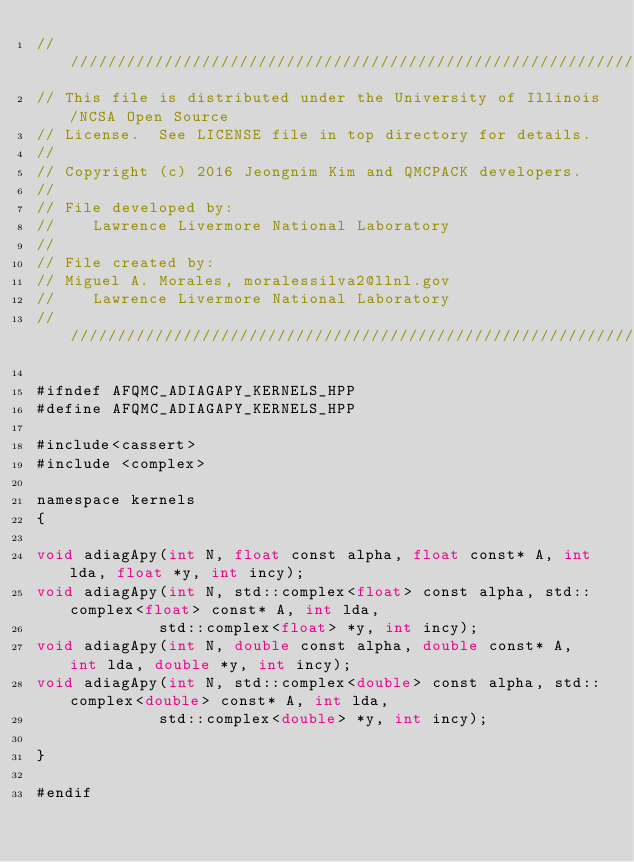<code> <loc_0><loc_0><loc_500><loc_500><_Cuda_>//////////////////////////////////////////////////////////////////////
// This file is distributed under the University of Illinois/NCSA Open Source
// License.  See LICENSE file in top directory for details.
//
// Copyright (c) 2016 Jeongnim Kim and QMCPACK developers.
//
// File developed by:
//    Lawrence Livermore National Laboratory
//
// File created by:
// Miguel A. Morales, moralessilva2@llnl.gov
//    Lawrence Livermore National Laboratory
////////////////////////////////////////////////////////////////////////////////

#ifndef AFQMC_ADIAGAPY_KERNELS_HPP
#define AFQMC_ADIAGAPY_KERNELS_HPP

#include<cassert>
#include <complex>

namespace kernels
{

void adiagApy(int N, float const alpha, float const* A, int lda, float *y, int incy); 
void adiagApy(int N, std::complex<float> const alpha, std::complex<float> const* A, int lda, 
             std::complex<float> *y, int incy); 
void adiagApy(int N, double const alpha, double const* A, int lda, double *y, int incy); 
void adiagApy(int N, std::complex<double> const alpha, std::complex<double> const* A, int lda, 
             std::complex<double> *y, int incy); 

}

#endif
</code> 